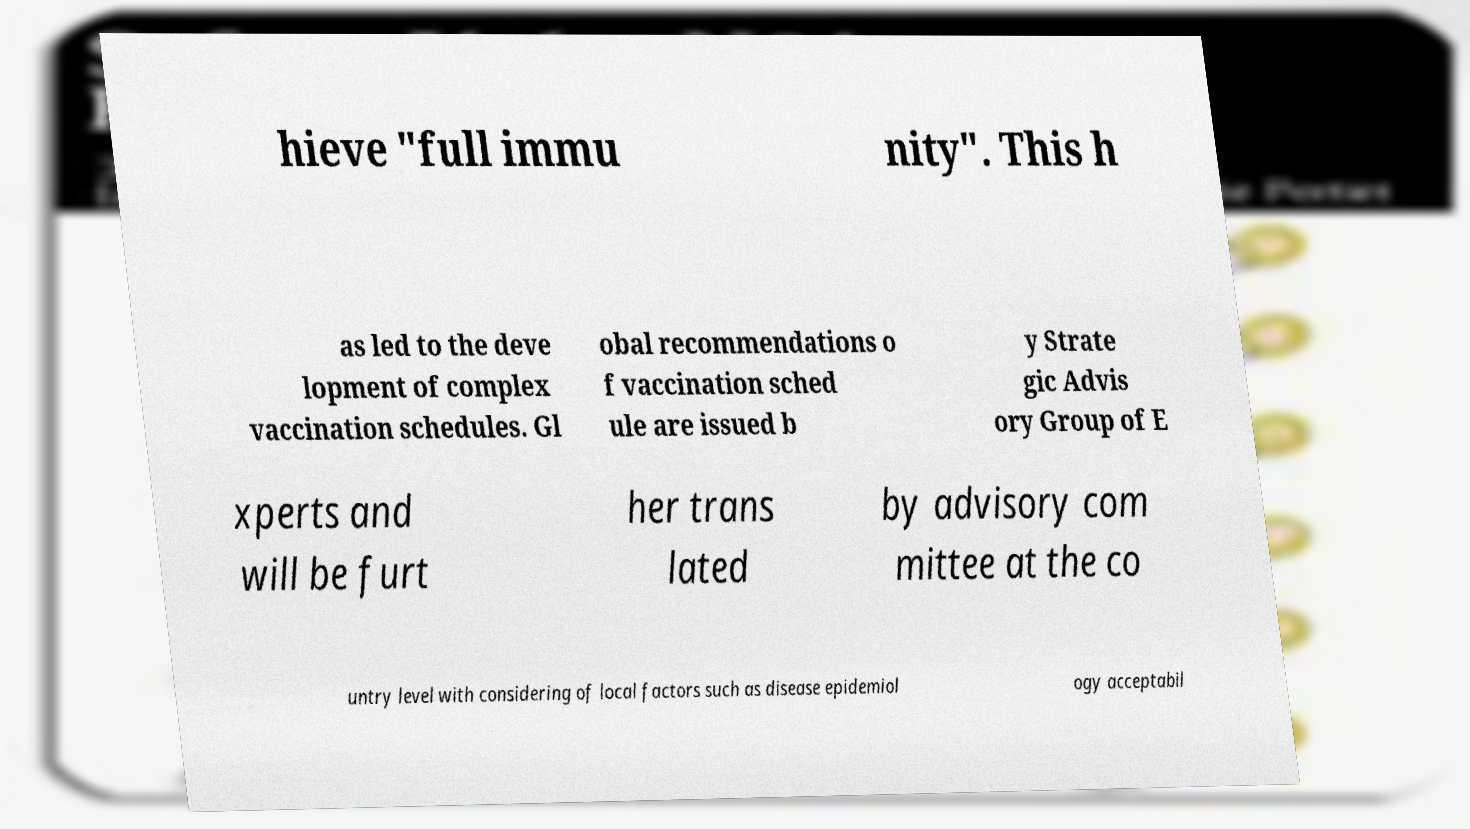Can you accurately transcribe the text from the provided image for me? hieve "full immu nity". This h as led to the deve lopment of complex vaccination schedules. Gl obal recommendations o f vaccination sched ule are issued b y Strate gic Advis ory Group of E xperts and will be furt her trans lated by advisory com mittee at the co untry level with considering of local factors such as disease epidemiol ogy acceptabil 